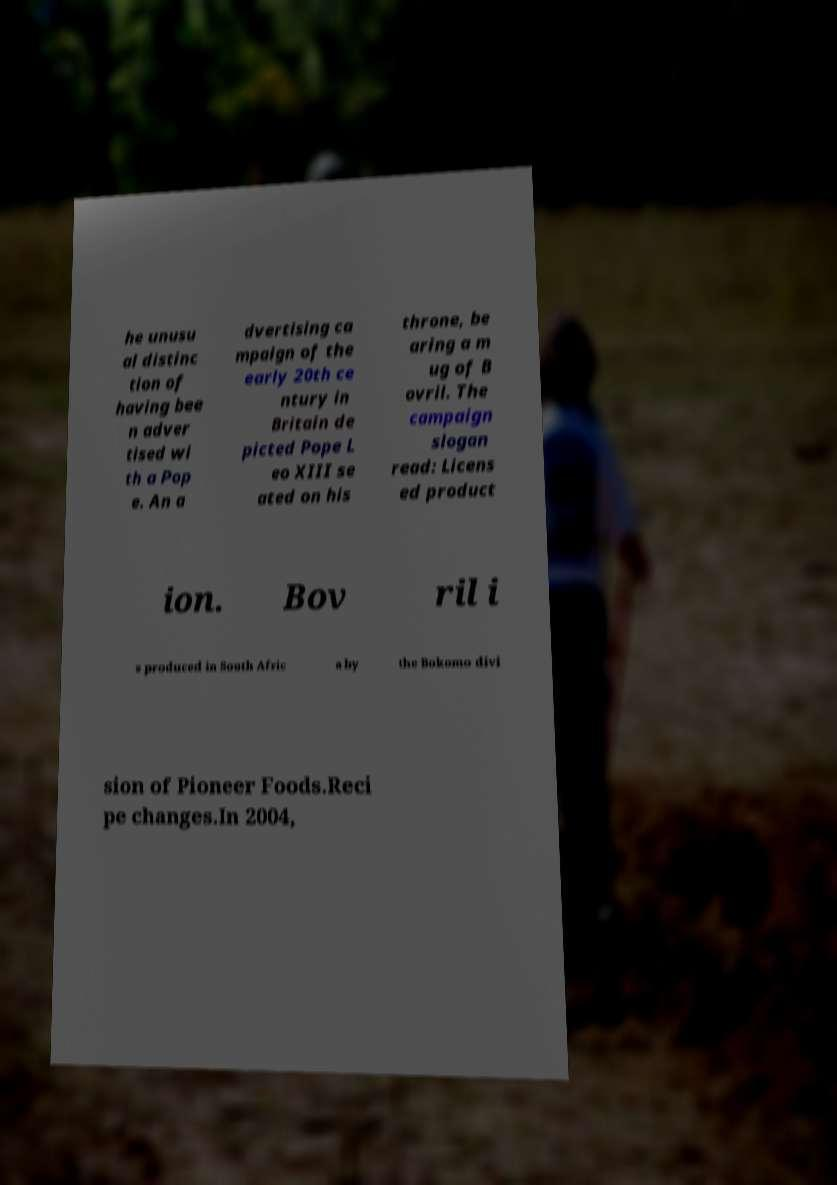Could you extract and type out the text from this image? he unusu al distinc tion of having bee n adver tised wi th a Pop e. An a dvertising ca mpaign of the early 20th ce ntury in Britain de picted Pope L eo XIII se ated on his throne, be aring a m ug of B ovril. The campaign slogan read: Licens ed product ion. Bov ril i s produced in South Afric a by the Bokomo divi sion of Pioneer Foods.Reci pe changes.In 2004, 